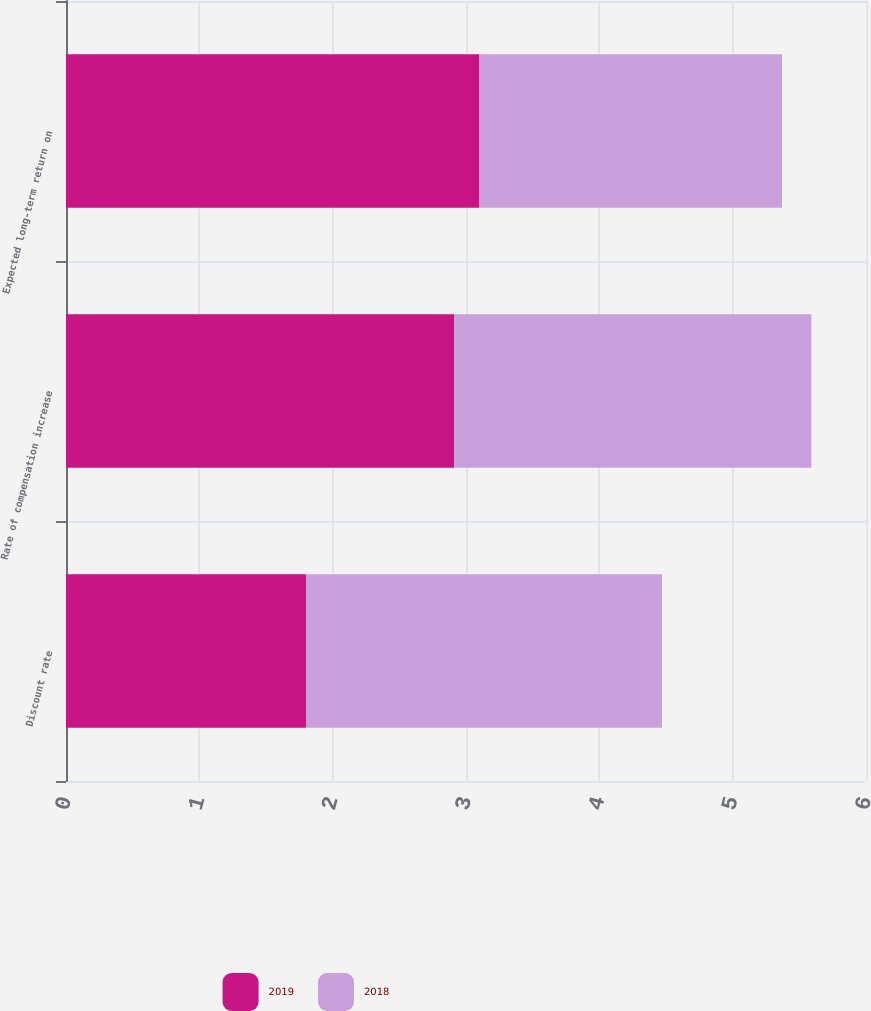<chart> <loc_0><loc_0><loc_500><loc_500><stacked_bar_chart><ecel><fcel>Discount rate<fcel>Rate of compensation increase<fcel>Expected long-term return on<nl><fcel>2019<fcel>1.8<fcel>2.91<fcel>3.1<nl><fcel>2018<fcel>2.67<fcel>2.68<fcel>2.27<nl></chart> 